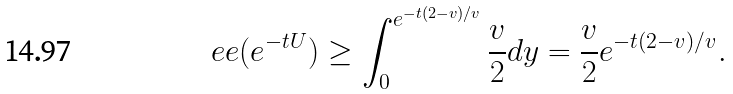Convert formula to latex. <formula><loc_0><loc_0><loc_500><loc_500>\ e e ( e ^ { - t U } ) \geq \int _ { 0 } ^ { e ^ { - t ( 2 - v ) / v } } \frac { v } { 2 } d y = \frac { v } { 2 } e ^ { - t ( 2 - v ) / v } .</formula> 